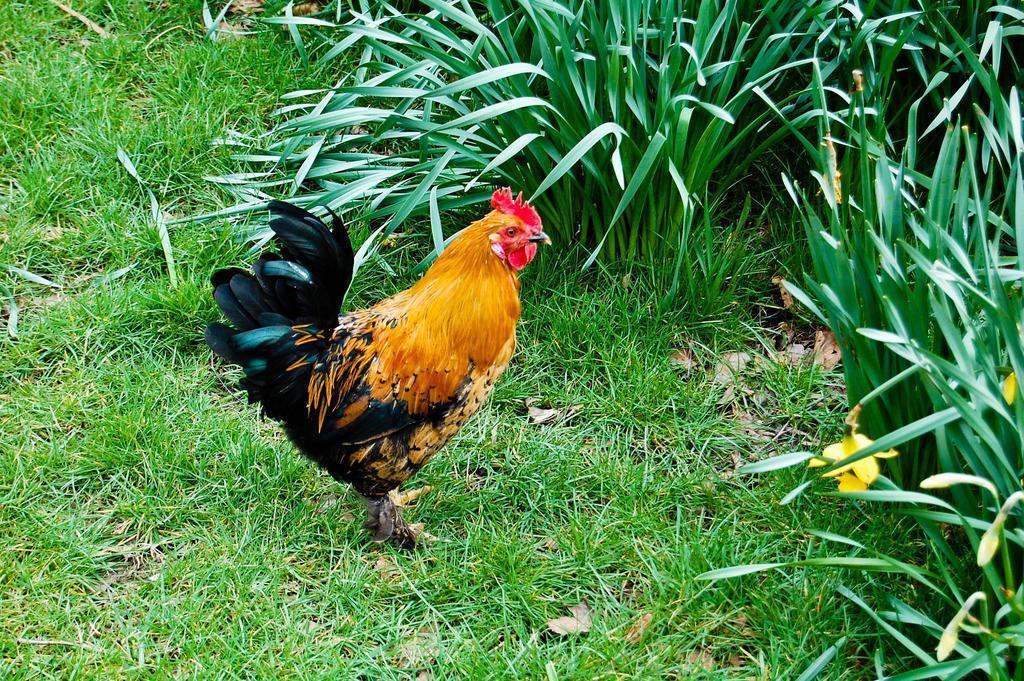In one or two sentences, can you explain what this image depicts? In this picture we can see a hen standing on the grass path and behind the hen there are plants. 